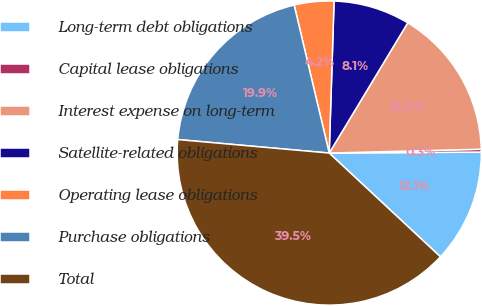<chart> <loc_0><loc_0><loc_500><loc_500><pie_chart><fcel>Long-term debt obligations<fcel>Capital lease obligations<fcel>Interest expense on long-term<fcel>Satellite-related obligations<fcel>Operating lease obligations<fcel>Purchase obligations<fcel>Total<nl><fcel>12.05%<fcel>0.3%<fcel>15.96%<fcel>8.13%<fcel>4.21%<fcel>19.88%<fcel>39.47%<nl></chart> 